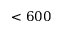<formula> <loc_0><loc_0><loc_500><loc_500>< 6 0 0</formula> 